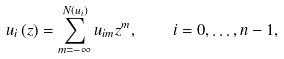Convert formula to latex. <formula><loc_0><loc_0><loc_500><loc_500>u _ { i } \left ( z \right ) = \sum _ { m = - \infty } ^ { N \left ( u _ { i } \right ) } u _ { i m } z ^ { m } , \quad i = 0 , \dots , n - 1 ,</formula> 